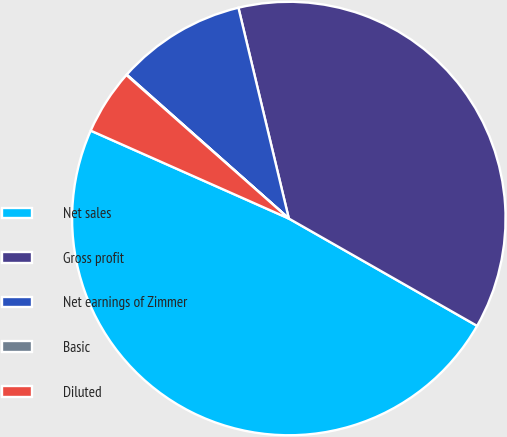Convert chart to OTSL. <chart><loc_0><loc_0><loc_500><loc_500><pie_chart><fcel>Net sales<fcel>Gross profit<fcel>Net earnings of Zimmer<fcel>Basic<fcel>Diluted<nl><fcel>48.4%<fcel>36.98%<fcel>9.71%<fcel>0.04%<fcel>4.87%<nl></chart> 